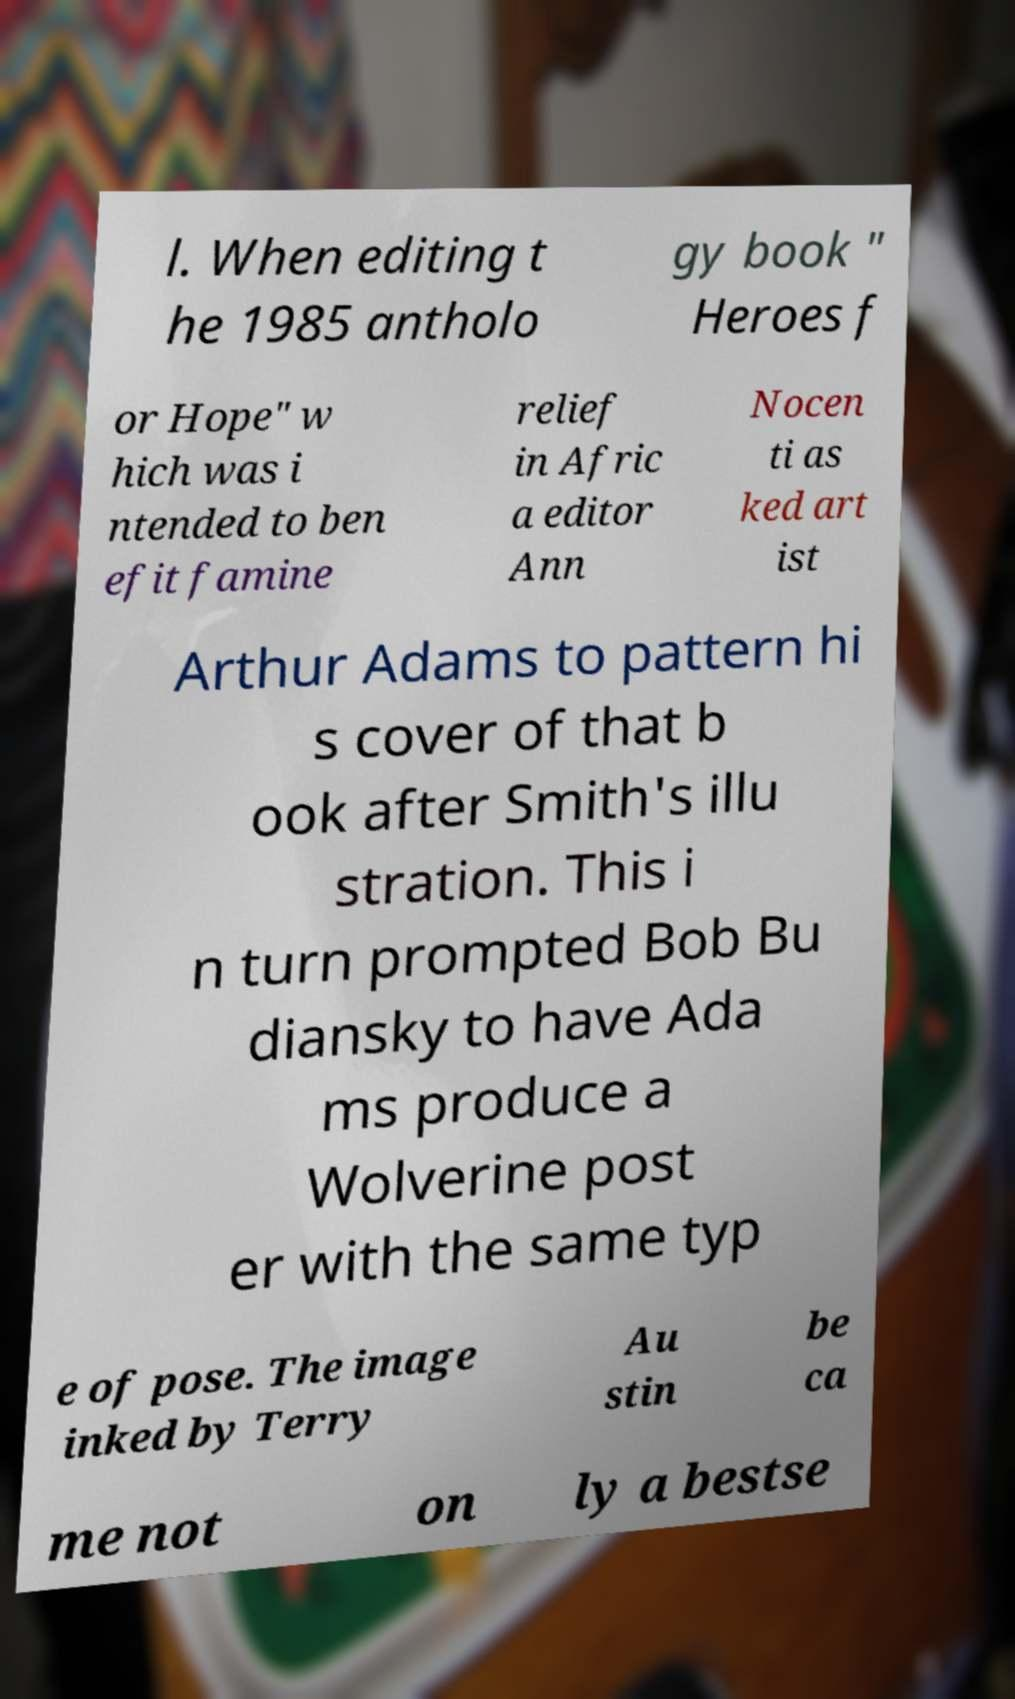What messages or text are displayed in this image? I need them in a readable, typed format. l. When editing t he 1985 antholo gy book " Heroes f or Hope" w hich was i ntended to ben efit famine relief in Afric a editor Ann Nocen ti as ked art ist Arthur Adams to pattern hi s cover of that b ook after Smith's illu stration. This i n turn prompted Bob Bu diansky to have Ada ms produce a Wolverine post er with the same typ e of pose. The image inked by Terry Au stin be ca me not on ly a bestse 